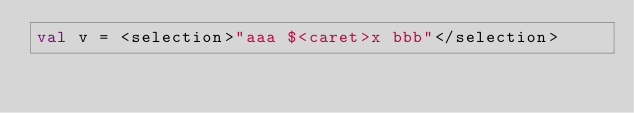Convert code to text. <code><loc_0><loc_0><loc_500><loc_500><_Kotlin_>val v = <selection>"aaa $<caret>x bbb"</selection></code> 